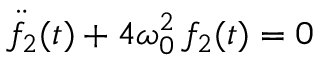Convert formula to latex. <formula><loc_0><loc_0><loc_500><loc_500>\ddot { f } _ { 2 } ( t ) + 4 \omega _ { 0 } ^ { 2 } \, f _ { 2 } ( t ) = 0</formula> 